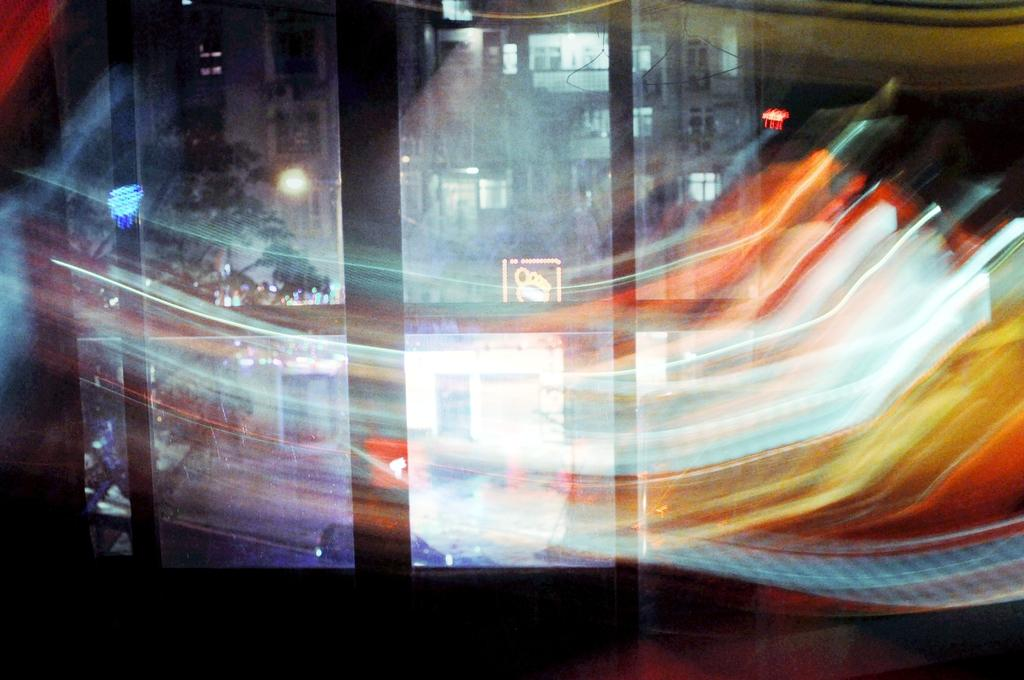What type of structures can be seen in the image? There are buildings in the image. What can be seen illuminating the scene? There are lights in the image. What type of natural elements are present in the image? There are trees in the image. What architectural features are visible in the buildings? There are windows visible in the image. Can you describe the quality of some parts of the image? Some parts of the image are blurred. What type of treatment is being administered to the trees in the image? There is no treatment being administered to the trees in the image; they are simply present in the scene. 